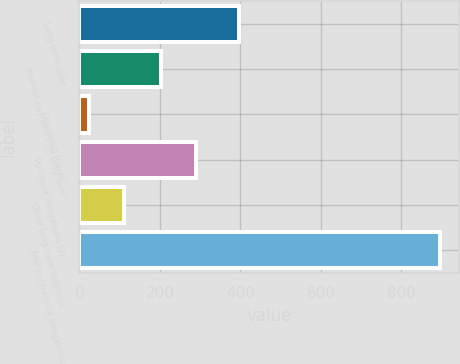<chart> <loc_0><loc_0><loc_500><loc_500><bar_chart><fcel>Long-term debt<fcel>Interest payments on long-term<fcel>Operating leases<fcel>Purchase obligations (2)<fcel>Other long-term liabilities<fcel>Total contractual obligations<nl><fcel>396<fcel>202<fcel>23<fcel>289.4<fcel>110.4<fcel>897<nl></chart> 